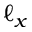Convert formula to latex. <formula><loc_0><loc_0><loc_500><loc_500>\ell _ { x }</formula> 